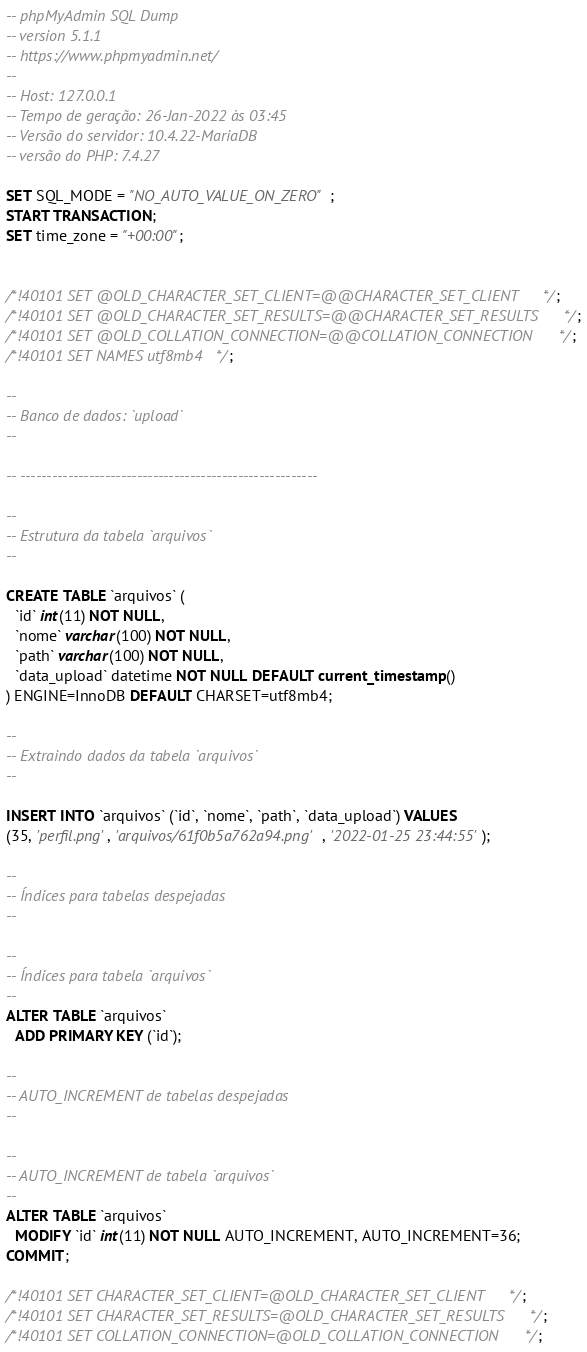Convert code to text. <code><loc_0><loc_0><loc_500><loc_500><_SQL_>-- phpMyAdmin SQL Dump
-- version 5.1.1
-- https://www.phpmyadmin.net/
--
-- Host: 127.0.0.1
-- Tempo de geração: 26-Jan-2022 às 03:45
-- Versão do servidor: 10.4.22-MariaDB
-- versão do PHP: 7.4.27

SET SQL_MODE = "NO_AUTO_VALUE_ON_ZERO";
START TRANSACTION;
SET time_zone = "+00:00";


/*!40101 SET @OLD_CHARACTER_SET_CLIENT=@@CHARACTER_SET_CLIENT */;
/*!40101 SET @OLD_CHARACTER_SET_RESULTS=@@CHARACTER_SET_RESULTS */;
/*!40101 SET @OLD_COLLATION_CONNECTION=@@COLLATION_CONNECTION */;
/*!40101 SET NAMES utf8mb4 */;

--
-- Banco de dados: `upload`
--

-- --------------------------------------------------------

--
-- Estrutura da tabela `arquivos`
--

CREATE TABLE `arquivos` (
  `id` int(11) NOT NULL,
  `nome` varchar(100) NOT NULL,
  `path` varchar(100) NOT NULL,
  `data_upload` datetime NOT NULL DEFAULT current_timestamp()
) ENGINE=InnoDB DEFAULT CHARSET=utf8mb4;

--
-- Extraindo dados da tabela `arquivos`
--

INSERT INTO `arquivos` (`id`, `nome`, `path`, `data_upload`) VALUES
(35, 'perfil.png', 'arquivos/61f0b5a762a94.png', '2022-01-25 23:44:55');

--
-- Índices para tabelas despejadas
--

--
-- Índices para tabela `arquivos`
--
ALTER TABLE `arquivos`
  ADD PRIMARY KEY (`id`);

--
-- AUTO_INCREMENT de tabelas despejadas
--

--
-- AUTO_INCREMENT de tabela `arquivos`
--
ALTER TABLE `arquivos`
  MODIFY `id` int(11) NOT NULL AUTO_INCREMENT, AUTO_INCREMENT=36;
COMMIT;

/*!40101 SET CHARACTER_SET_CLIENT=@OLD_CHARACTER_SET_CLIENT */;
/*!40101 SET CHARACTER_SET_RESULTS=@OLD_CHARACTER_SET_RESULTS */;
/*!40101 SET COLLATION_CONNECTION=@OLD_COLLATION_CONNECTION */;
</code> 